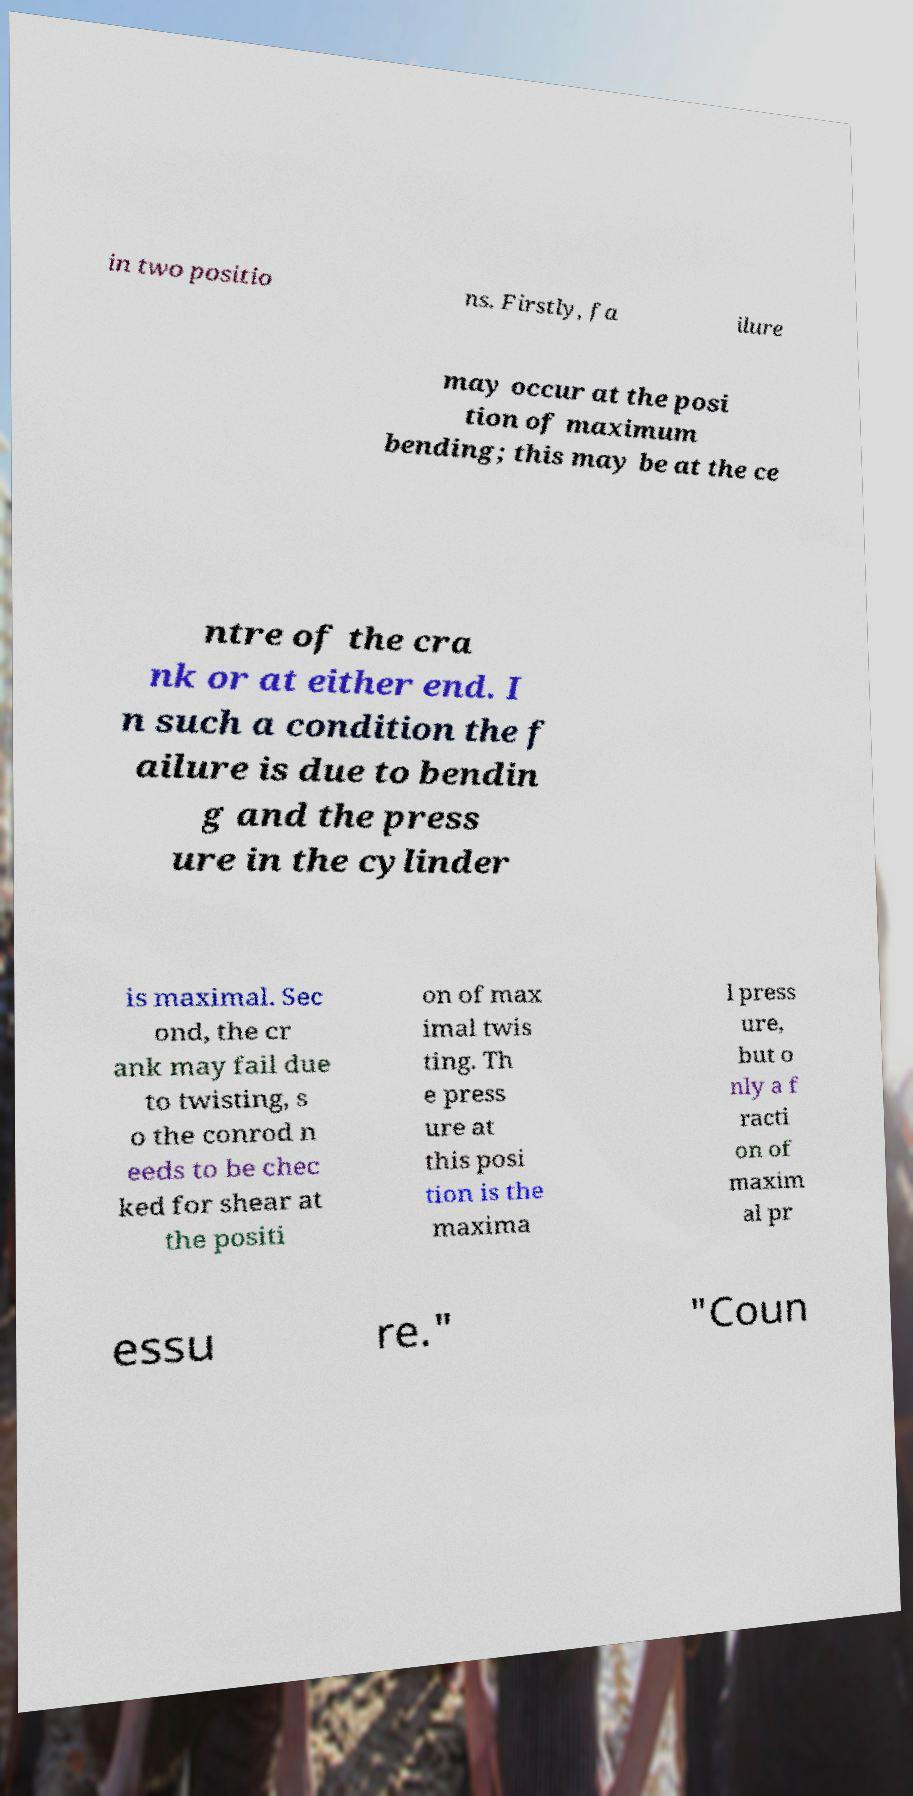I need the written content from this picture converted into text. Can you do that? in two positio ns. Firstly, fa ilure may occur at the posi tion of maximum bending; this may be at the ce ntre of the cra nk or at either end. I n such a condition the f ailure is due to bendin g and the press ure in the cylinder is maximal. Sec ond, the cr ank may fail due to twisting, s o the conrod n eeds to be chec ked for shear at the positi on of max imal twis ting. Th e press ure at this posi tion is the maxima l press ure, but o nly a f racti on of maxim al pr essu re." "Coun 